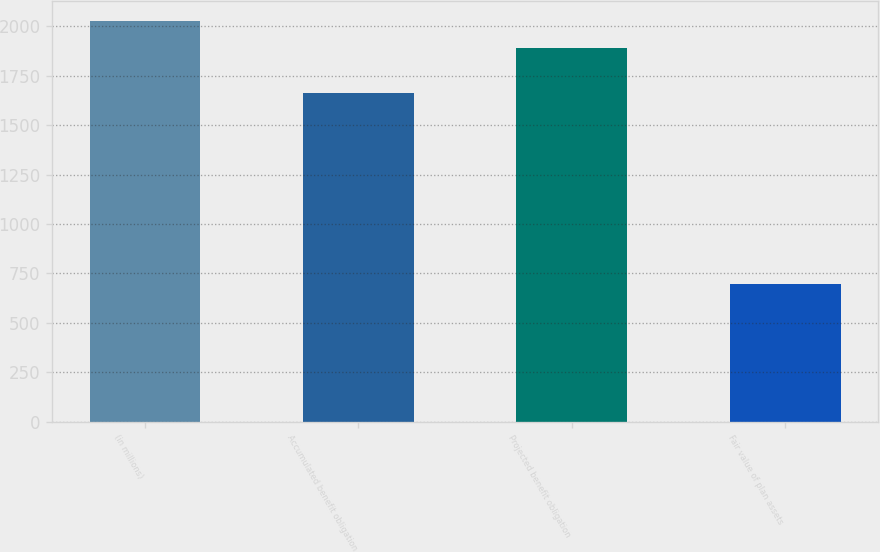<chart> <loc_0><loc_0><loc_500><loc_500><bar_chart><fcel>(in millions)<fcel>Accumulated benefit obligation<fcel>Projected benefit obligation<fcel>Fair value of plan assets<nl><fcel>2024.1<fcel>1664<fcel>1892<fcel>696<nl></chart> 